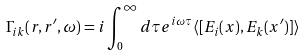<formula> <loc_0><loc_0><loc_500><loc_500>\Gamma _ { i k } ( r , r ^ { \prime } , \omega ) = i \int _ { 0 } ^ { \infty } d \tau e ^ { i \omega \tau } \langle [ E _ { i } ( x ) , E _ { k } ( x ^ { \prime } ) ] \rangle</formula> 